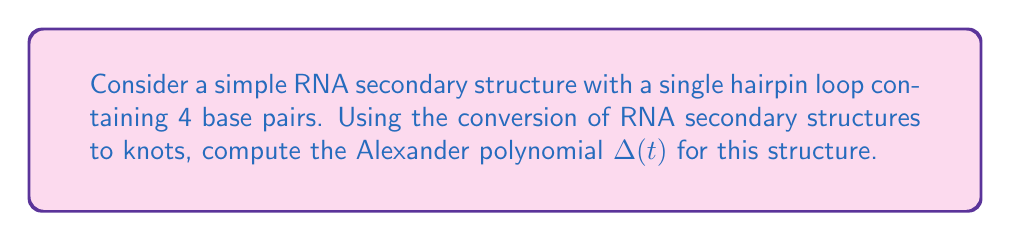What is the answer to this math problem? To compute the Alexander polynomial for this RNA secondary structure, we'll follow these steps:

1. Convert the RNA secondary structure to a knot diagram:
   - The hairpin loop with 4 base pairs can be represented as a trefoil knot.

2. Create the Seifert matrix $V$ for the trefoil knot:
   The Seifert matrix for a trefoil knot is:
   $$V = \begin{pmatrix}
   1 & 1 \\
   0 & 1
   \end{pmatrix}$$

3. Calculate $V - tV^T$:
   $$V - tV^T = \begin{pmatrix}
   1 & 1 \\
   0 & 1
   \end{pmatrix} - t\begin{pmatrix}
   1 & 0 \\
   1 & 1
   \end{pmatrix} = \begin{pmatrix}
   1-t & 1-t \\
   -t & 1-t
   \end{pmatrix}$$

4. Compute the determinant of $V - tV^T$:
   $$\det(V - tV^T) = (1-t)(1-t) - (-t)(1-t) = (1-t)^2 + t(1-t)$$

5. Simplify the expression:
   $$(1-t)^2 + t(1-t) = 1-2t+t^2 + t-t^2 = 1-t+t^2$$

6. The Alexander polynomial $\Delta(t)$ is the determinant of $V - tV^T$ up to a factor of $\pm t^k$, where $k$ is an integer. In this case, we can use the polynomial as is.

Therefore, the Alexander polynomial for this RNA secondary structure is:
$$\Delta(t) = 1-t+t^2$$
Answer: $\Delta(t) = 1-t+t^2$ 